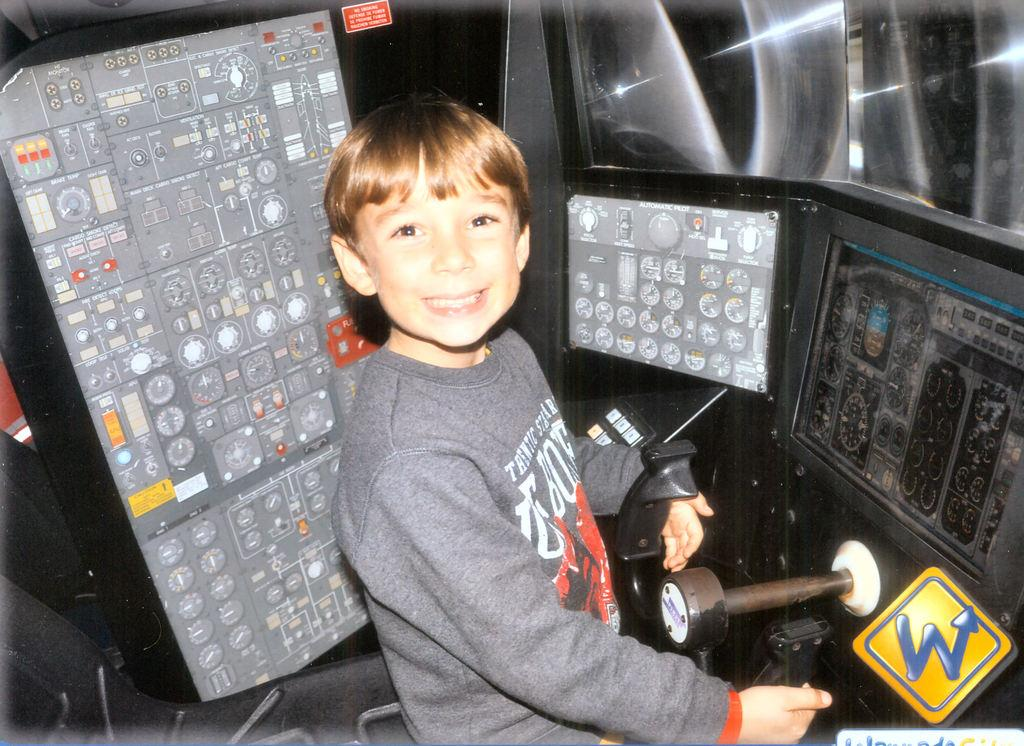Provide a one-sentence caption for the provided image. A boy poses to get his picture taken the the cockpit of an airplane at a place named W. 